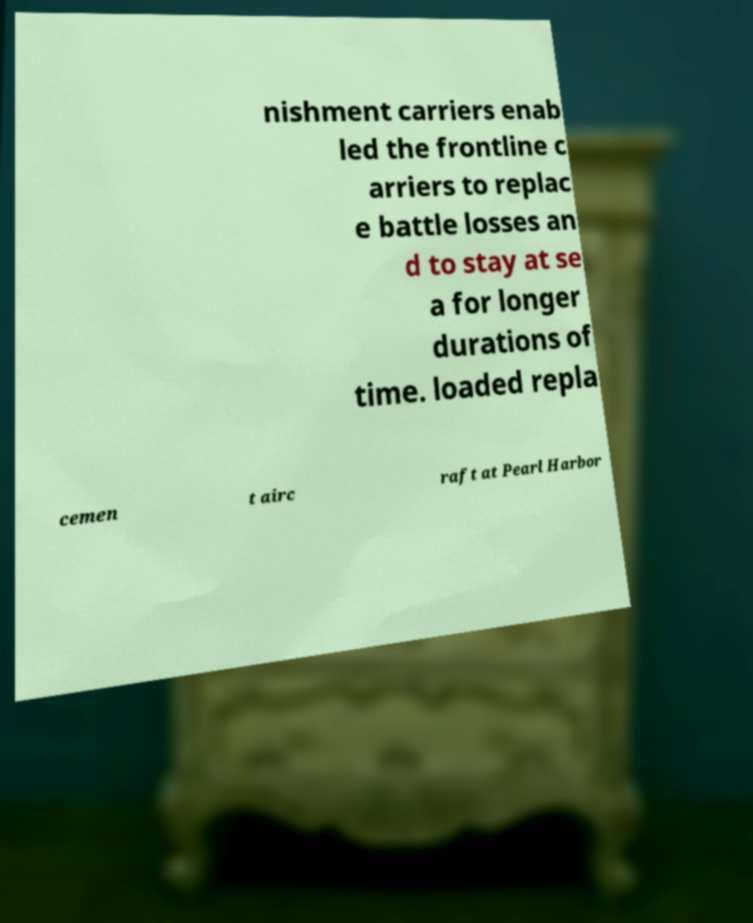Can you accurately transcribe the text from the provided image for me? nishment carriers enab led the frontline c arriers to replac e battle losses an d to stay at se a for longer durations of time. loaded repla cemen t airc raft at Pearl Harbor 